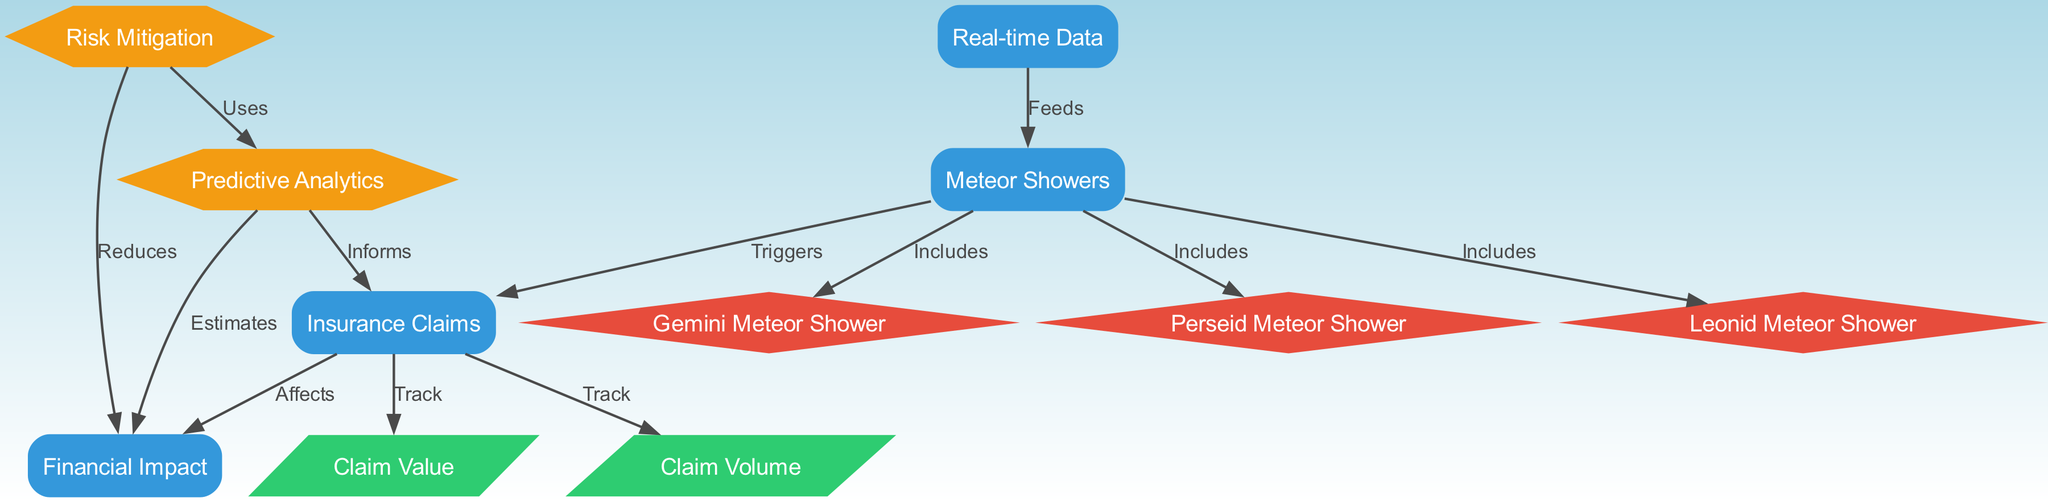What are the three types of meteor showers included in the diagram? The diagram includes "Perseid Meteor Shower," "Leonid Meteor Shower," and "Gemini Meteor Shower" as indicated by the connections from "Meteor Showers."
Answer: Perseid Meteor Shower, Leonid Meteor Shower, Gemini Meteor Shower How many nodes are related to Insurance Claims? There are four nodes directly related to "Insurance Claims": "Meteor Showers," "Financial Impact," "Claim Volume," and "Claim Value" as they all connect directly or indirectly to "Insurance Claims."
Answer: Four What does "Real-time Data" feed into? "Real-time Data" feeds into "Meteor Showers," which indicates that real-time information helps monitor the frequency of meteor showers.
Answer: Meteor Showers What is the relationship between "Insurance Claims" and "Financial Impact"? The relationship is indicated by the label "Affects," showing that "Insurance Claims" has an effect on the "Financial Impact."
Answer: Affects Which node estimates the Financial Impact? The node "Predictive Analytics" estimates the Financial Impact as indicated by the connection from "Predictive Analytics" to "Financial Impact" with the label "Estimates."
Answer: Predictive Analytics How many types of claims are being tracked in the diagram? There are two types of claims being tracked: "Claim Volume" and "Claim Value," as indicated by the edges connecting both to "Insurance Claims."
Answer: Two How does risk mitigation impact financial implications? "Risk Mitigation" reduces the "Financial Impact," showing that applying risk management strategies can lower financial losses due to insurance claims.
Answer: Reduces Which node informs the Insurance Claims? "Predictive Analytics" informs the "Insurance Claims," as indicated by the diagram's flow where it connects with the label "Informs."
Answer: Predictive Analytics What type of edge connects "Meteor Showers" to "Insurance Claims"? The edge that connects them is labeled "Triggers," indicating that meteor showers can trigger insurance claims.
Answer: Triggers 